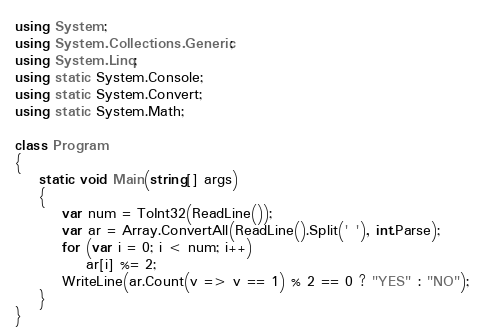Convert code to text. <code><loc_0><loc_0><loc_500><loc_500><_C#_>using System;
using System.Collections.Generic;
using System.Linq;
using static System.Console;
using static System.Convert;
using static System.Math;

class Program
{
    static void Main(string[] args)
    {
        var num = ToInt32(ReadLine());
        var ar = Array.ConvertAll(ReadLine().Split(' '), int.Parse);
        for (var i = 0; i < num; i++)
            ar[i] %= 2;
        WriteLine(ar.Count(v => v == 1) % 2 == 0 ? "YES" : "NO");
    }
}
</code> 